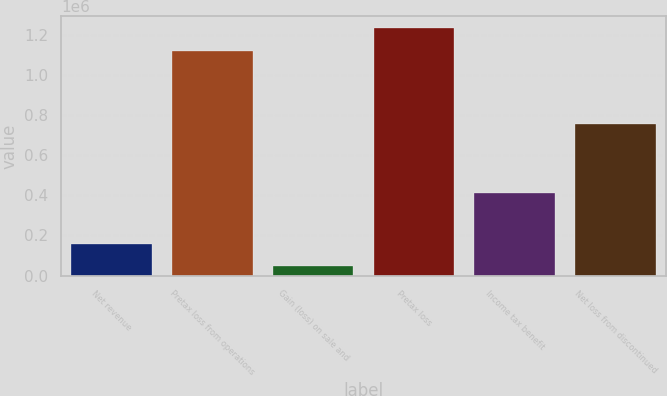Convert chart to OTSL. <chart><loc_0><loc_0><loc_500><loc_500><bar_chart><fcel>Net revenue<fcel>Pretax loss from operations<fcel>Gain (loss) on sale and<fcel>Pretax loss<fcel>Income tax benefit<fcel>Net loss from discontinued<nl><fcel>157532<fcel>1.12022e+06<fcel>45510<fcel>1.23224e+06<fcel>411132<fcel>754594<nl></chart> 